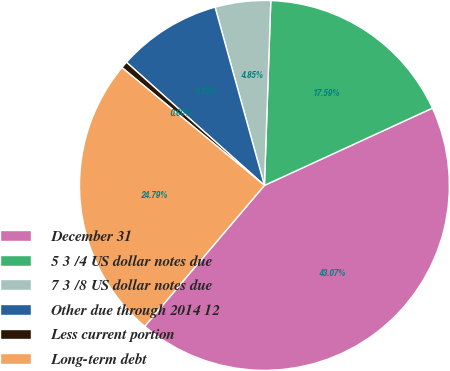<chart> <loc_0><loc_0><loc_500><loc_500><pie_chart><fcel>December 31<fcel>5 3 /4 US dollar notes due<fcel>7 3 /8 US dollar notes due<fcel>Other due through 2014 12<fcel>Less current portion<fcel>Long-term debt<nl><fcel>43.07%<fcel>17.59%<fcel>4.85%<fcel>9.1%<fcel>0.6%<fcel>24.79%<nl></chart> 